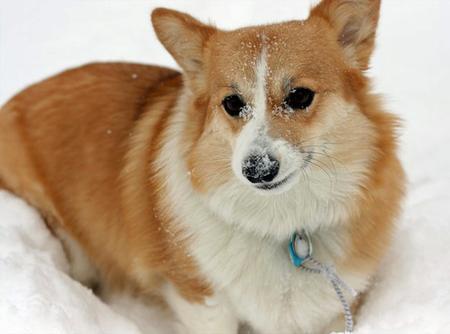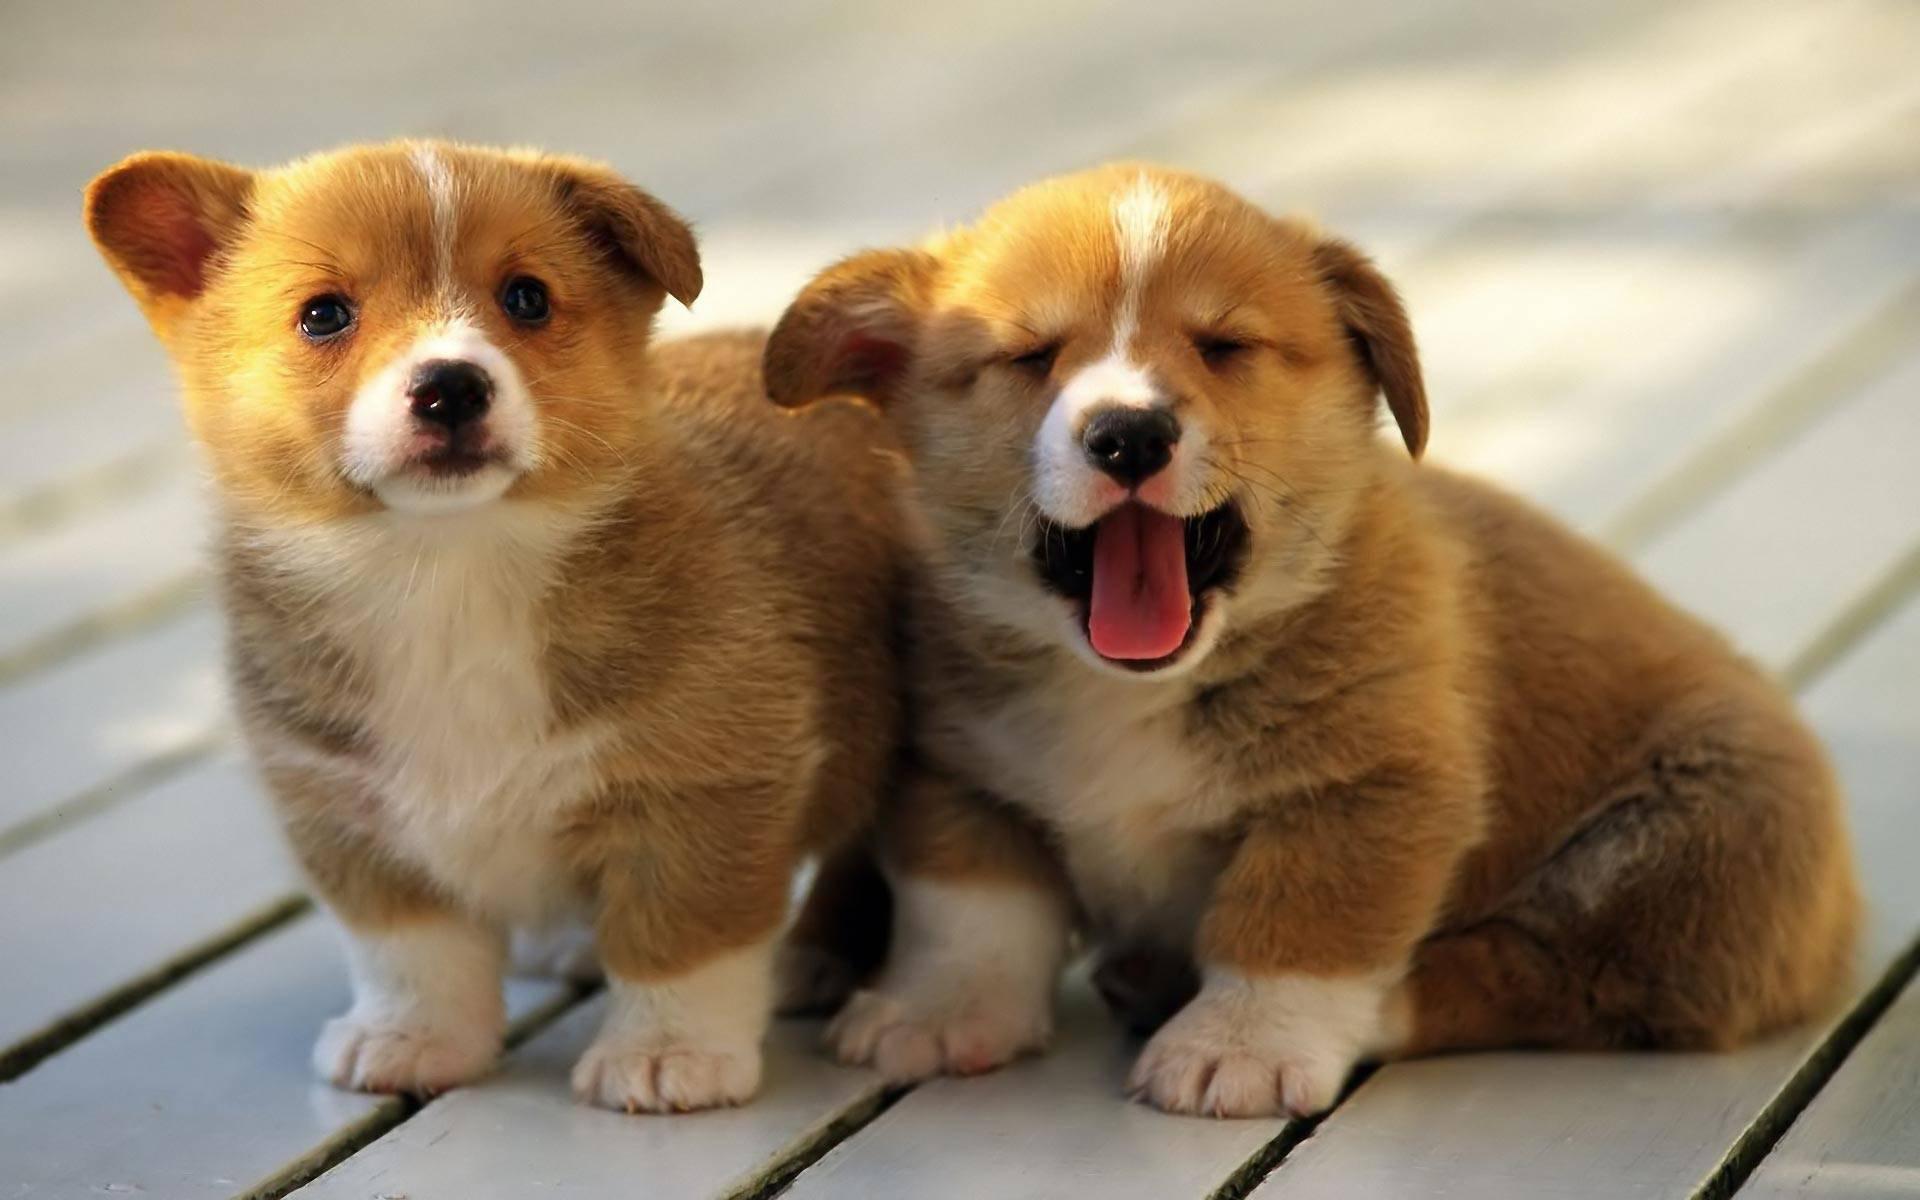The first image is the image on the left, the second image is the image on the right. Examine the images to the left and right. Is the description "The left image features a camera-gazing corgi with its tongue hanging out, and the right image shows a corgi standing rightward in profile, with its head turned forward." accurate? Answer yes or no. No. 